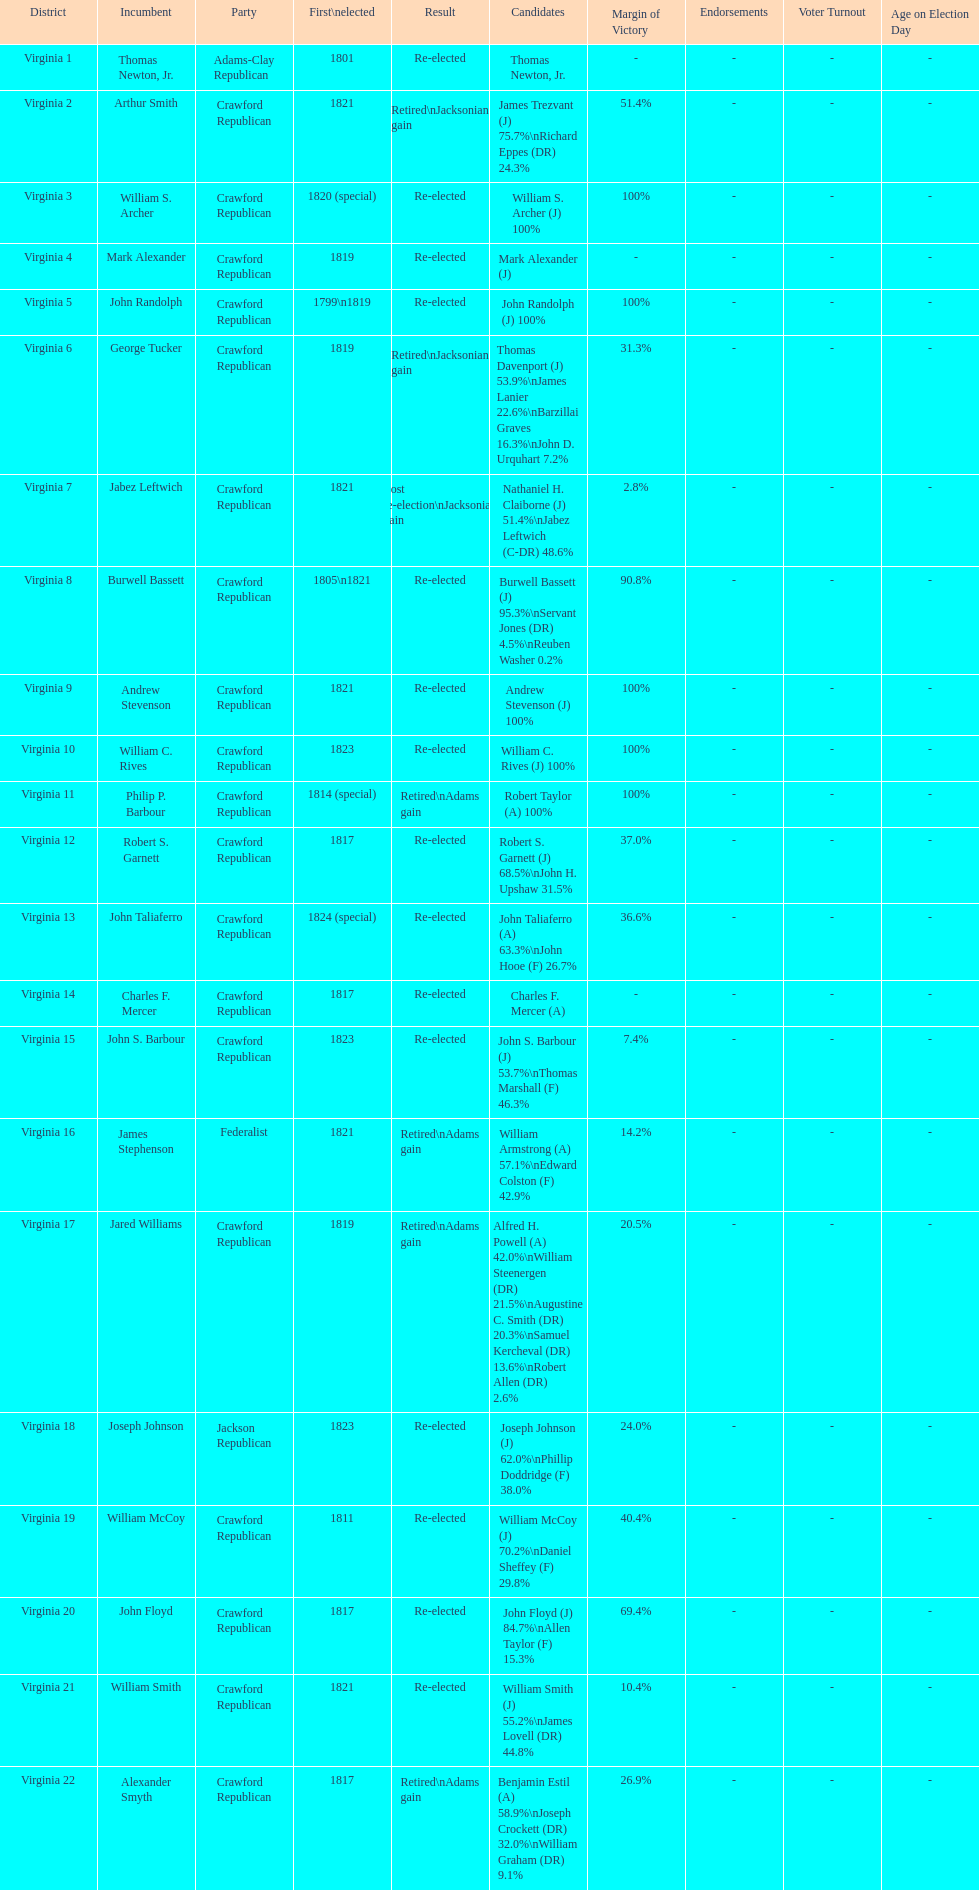How many candidates were there for virginia 17 district? 5. Would you be able to parse every entry in this table? {'header': ['District', 'Incumbent', 'Party', 'First\\nelected', 'Result', 'Candidates', 'Margin of Victory', 'Endorsements', 'Voter Turnout', 'Age on Election Day'], 'rows': [['Virginia 1', 'Thomas Newton, Jr.', 'Adams-Clay Republican', '1801', 'Re-elected', 'Thomas Newton, Jr.', '-', '-', '-', '-'], ['Virginia 2', 'Arthur Smith', 'Crawford Republican', '1821', 'Retired\\nJacksonian gain', 'James Trezvant (J) 75.7%\\nRichard Eppes (DR) 24.3%', '51.4%', '-', '-', '-'], ['Virginia 3', 'William S. Archer', 'Crawford Republican', '1820 (special)', 'Re-elected', 'William S. Archer (J) 100%', '100%', '-', '-', '-'], ['Virginia 4', 'Mark Alexander', 'Crawford Republican', '1819', 'Re-elected', 'Mark Alexander (J)', '-', '-', '-', '-'], ['Virginia 5', 'John Randolph', 'Crawford Republican', '1799\\n1819', 'Re-elected', 'John Randolph (J) 100%', '100%', '-', '-', '-'], ['Virginia 6', 'George Tucker', 'Crawford Republican', '1819', 'Retired\\nJacksonian gain', 'Thomas Davenport (J) 53.9%\\nJames Lanier 22.6%\\nBarzillai Graves 16.3%\\nJohn D. Urquhart 7.2%', '31.3%', '-', '-', '-'], ['Virginia 7', 'Jabez Leftwich', 'Crawford Republican', '1821', 'Lost re-election\\nJacksonian gain', 'Nathaniel H. Claiborne (J) 51.4%\\nJabez Leftwich (C-DR) 48.6%', '2.8%', '-', '-', '-'], ['Virginia 8', 'Burwell Bassett', 'Crawford Republican', '1805\\n1821', 'Re-elected', 'Burwell Bassett (J) 95.3%\\nServant Jones (DR) 4.5%\\nReuben Washer 0.2%', '90.8%', '-', '-', '-'], ['Virginia 9', 'Andrew Stevenson', 'Crawford Republican', '1821', 'Re-elected', 'Andrew Stevenson (J) 100%', '100%', '-', '-', '-'], ['Virginia 10', 'William C. Rives', 'Crawford Republican', '1823', 'Re-elected', 'William C. Rives (J) 100%', '100%', '-', '-', '-'], ['Virginia 11', 'Philip P. Barbour', 'Crawford Republican', '1814 (special)', 'Retired\\nAdams gain', 'Robert Taylor (A) 100%', '100%', '-', '-', '-'], ['Virginia 12', 'Robert S. Garnett', 'Crawford Republican', '1817', 'Re-elected', 'Robert S. Garnett (J) 68.5%\\nJohn H. Upshaw 31.5%', '37.0%', '-', '-', '-'], ['Virginia 13', 'John Taliaferro', 'Crawford Republican', '1824 (special)', 'Re-elected', 'John Taliaferro (A) 63.3%\\nJohn Hooe (F) 26.7%', '36.6%', '-', '-', '-'], ['Virginia 14', 'Charles F. Mercer', 'Crawford Republican', '1817', 'Re-elected', 'Charles F. Mercer (A)', '-', '-', '-', '-'], ['Virginia 15', 'John S. Barbour', 'Crawford Republican', '1823', 'Re-elected', 'John S. Barbour (J) 53.7%\\nThomas Marshall (F) 46.3%', '7.4%', '-', '-', '-'], ['Virginia 16', 'James Stephenson', 'Federalist', '1821', 'Retired\\nAdams gain', 'William Armstrong (A) 57.1%\\nEdward Colston (F) 42.9%', '14.2%', '-', '-', '-'], ['Virginia 17', 'Jared Williams', 'Crawford Republican', '1819', 'Retired\\nAdams gain', 'Alfred H. Powell (A) 42.0%\\nWilliam Steenergen (DR) 21.5%\\nAugustine C. Smith (DR) 20.3%\\nSamuel Kercheval (DR) 13.6%\\nRobert Allen (DR) 2.6%', '20.5%', '-', '-', '-'], ['Virginia 18', 'Joseph Johnson', 'Jackson Republican', '1823', 'Re-elected', 'Joseph Johnson (J) 62.0%\\nPhillip Doddridge (F) 38.0%', '24.0%', '-', '-', '-'], ['Virginia 19', 'William McCoy', 'Crawford Republican', '1811', 'Re-elected', 'William McCoy (J) 70.2%\\nDaniel Sheffey (F) 29.8%', '40.4%', '-', '-', '-'], ['Virginia 20', 'John Floyd', 'Crawford Republican', '1817', 'Re-elected', 'John Floyd (J) 84.7%\\nAllen Taylor (F) 15.3%', '69.4%', '-', '-', '-'], ['Virginia 21', 'William Smith', 'Crawford Republican', '1821', 'Re-elected', 'William Smith (J) 55.2%\\nJames Lovell (DR) 44.8%', '10.4%', '-', '-', '-'], ['Virginia 22', 'Alexander Smyth', 'Crawford Republican', '1817', 'Retired\\nAdams gain', 'Benjamin Estil (A) 58.9%\\nJoseph Crockett (DR) 32.0%\\nWilliam Graham (DR) 9.1%', '26.9%', '-', '-', '-']]} 